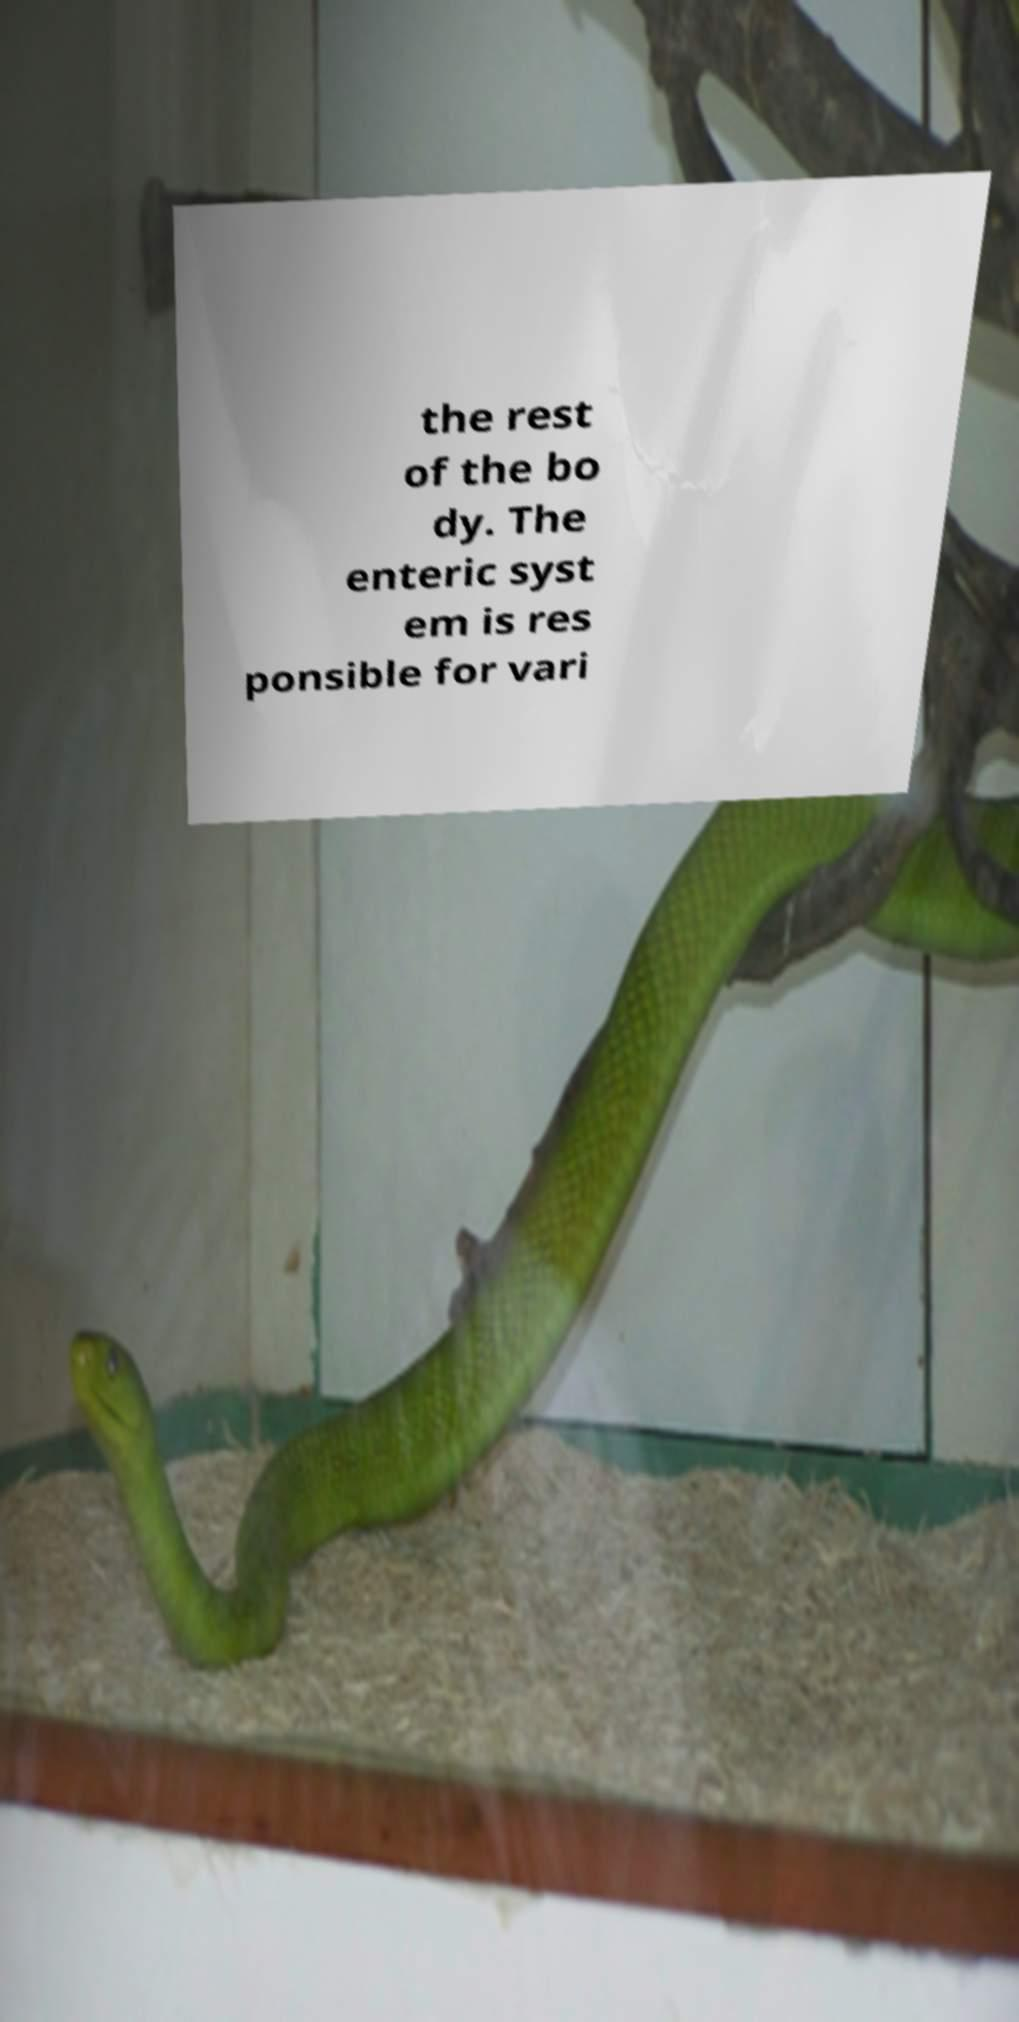Can you read and provide the text displayed in the image?This photo seems to have some interesting text. Can you extract and type it out for me? the rest of the bo dy. The enteric syst em is res ponsible for vari 